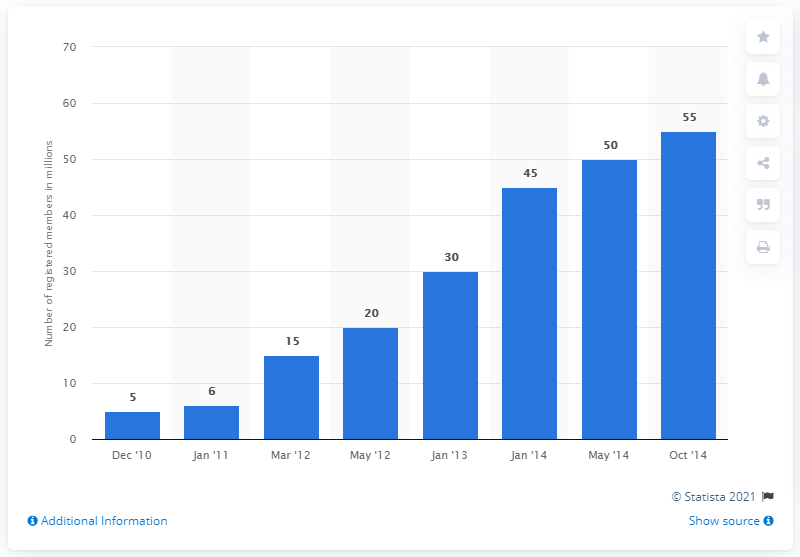Indicate a few pertinent items in this graphic. During the period of December 2010 to October 2014, Foursquare had 55 members. 